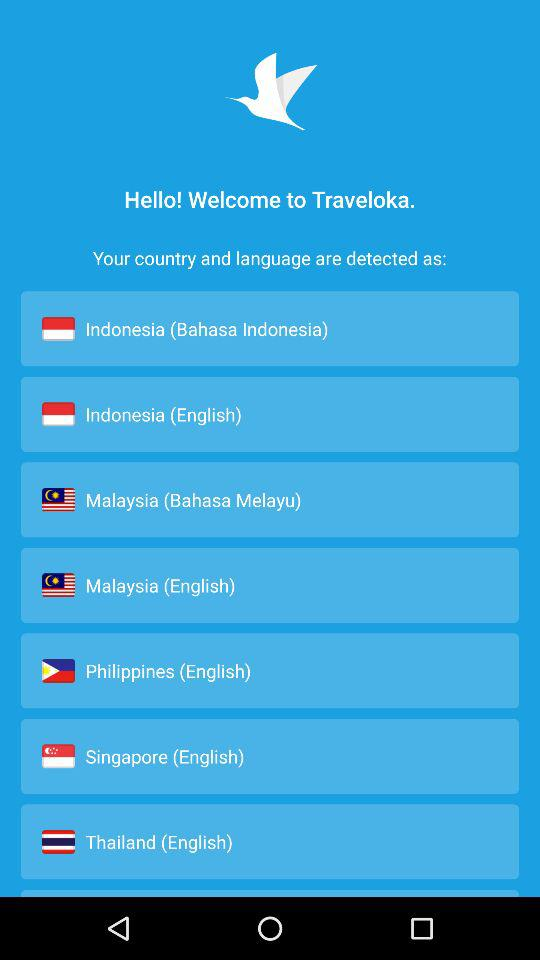What is the language of Singapore? The language of Singapore is English. 